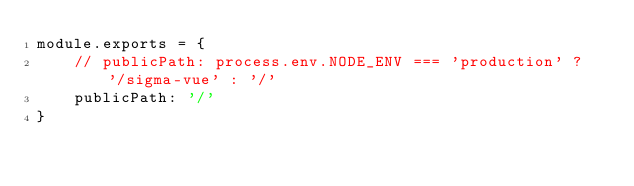Convert code to text. <code><loc_0><loc_0><loc_500><loc_500><_JavaScript_>module.exports = {
	// publicPath: process.env.NODE_ENV === 'production' ? '/sigma-vue' : '/'
	publicPath: '/'
}</code> 